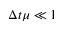Convert formula to latex. <formula><loc_0><loc_0><loc_500><loc_500>\Delta t \mu \ll 1</formula> 